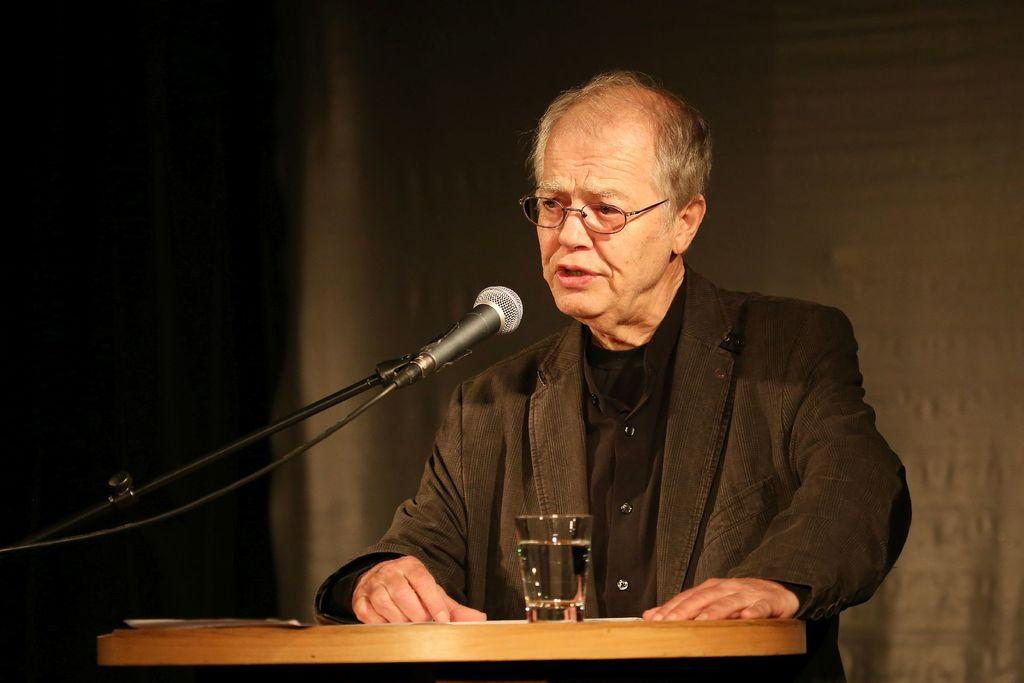Who or what is the main subject of the image? There is a person in the image. What is the person doing in the image? The person is standing on a dais and speaking into a microphone. What might be present near the person for hydration purposes? There is a glass of water in front of the person. What type of pie is being served to the person's sisters in the image? There is no pie or sisters present in the image; it features a person standing on a dais and speaking into a microphone. 